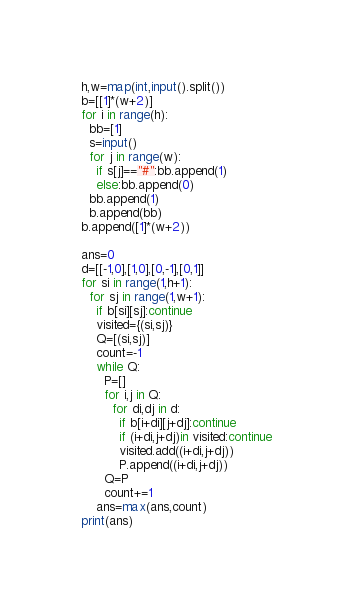<code> <loc_0><loc_0><loc_500><loc_500><_Python_>h,w=map(int,input().split())
b=[[1]*(w+2)]
for i in range(h):
  bb=[1]
  s=input()
  for j in range(w):
    if s[j]=="#":bb.append(1)
    else:bb.append(0)
  bb.append(1)
  b.append(bb)
b.append([1]*(w+2))

ans=0
d=[[-1,0],[1,0],[0,-1],[0,1]]
for si in range(1,h+1):
  for sj in range(1,w+1):
    if b[si][sj]:continue
    visited={(si,sj)}
    Q=[(si,sj)]
    count=-1
    while Q:
      P=[]
      for i,j in Q:
        for di,dj in d:
          if b[i+di][j+dj]:continue
          if (i+di,j+dj)in visited:continue
          visited.add((i+di,j+dj))
          P.append((i+di,j+dj))
      Q=P
      count+=1
    ans=max(ans,count)
print(ans)</code> 